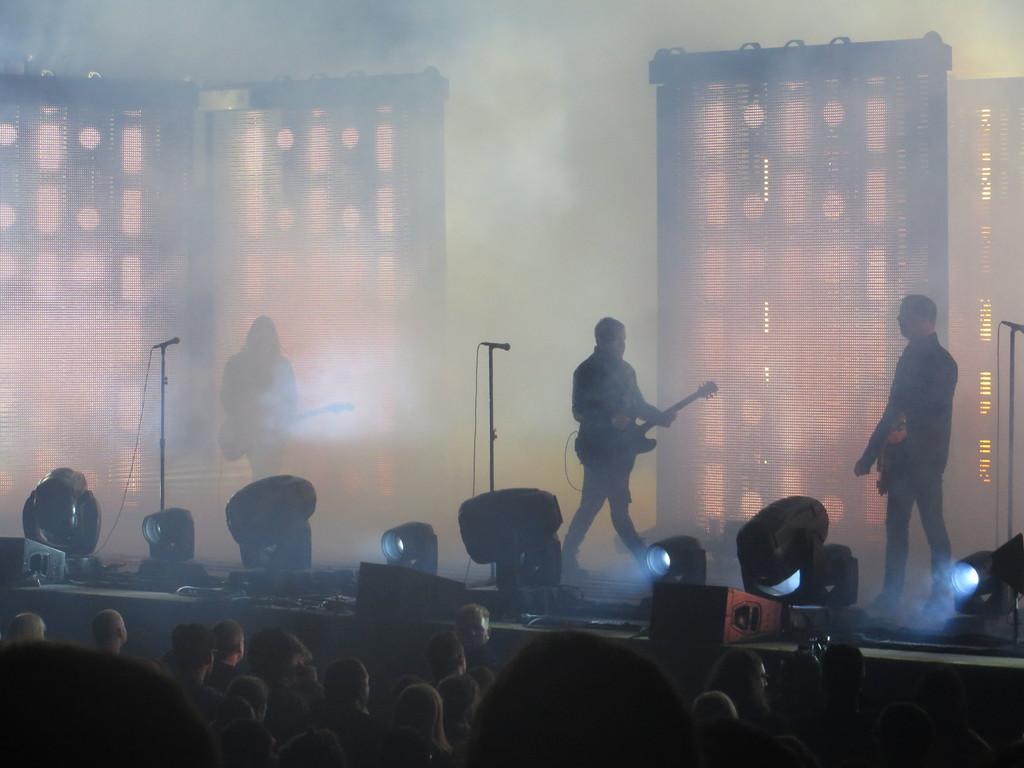Could you give a brief overview of what you see in this image? In this image, there are three people standing and holding the guitars. These are the mikes, which are attached to the mike stands. I can see the show lights. At the bottom of the image, I can see a group of people standing. These look like the screens. 